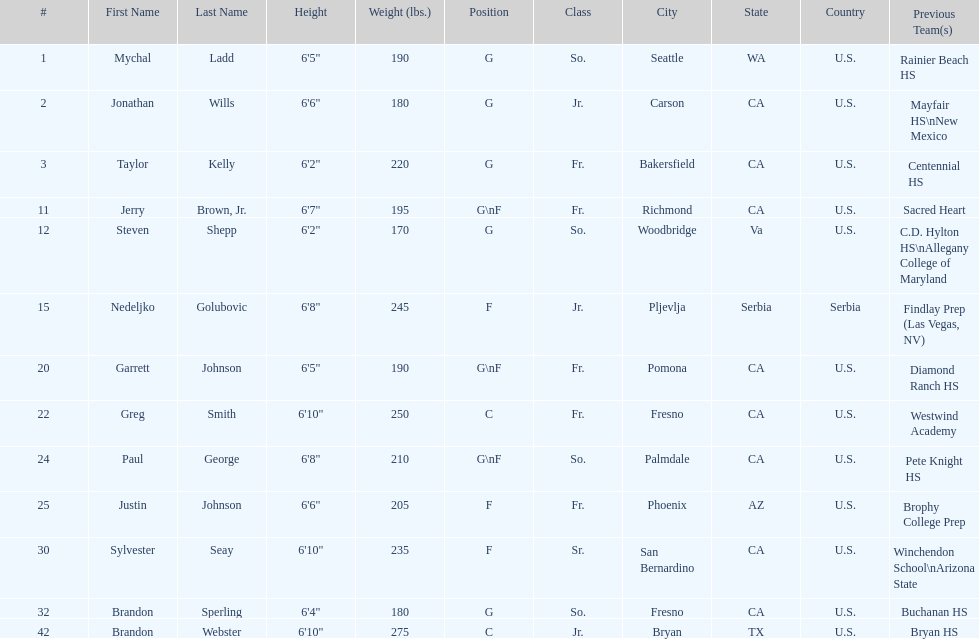Which player previously played for sacred heart? Jerry Brown, Jr. 